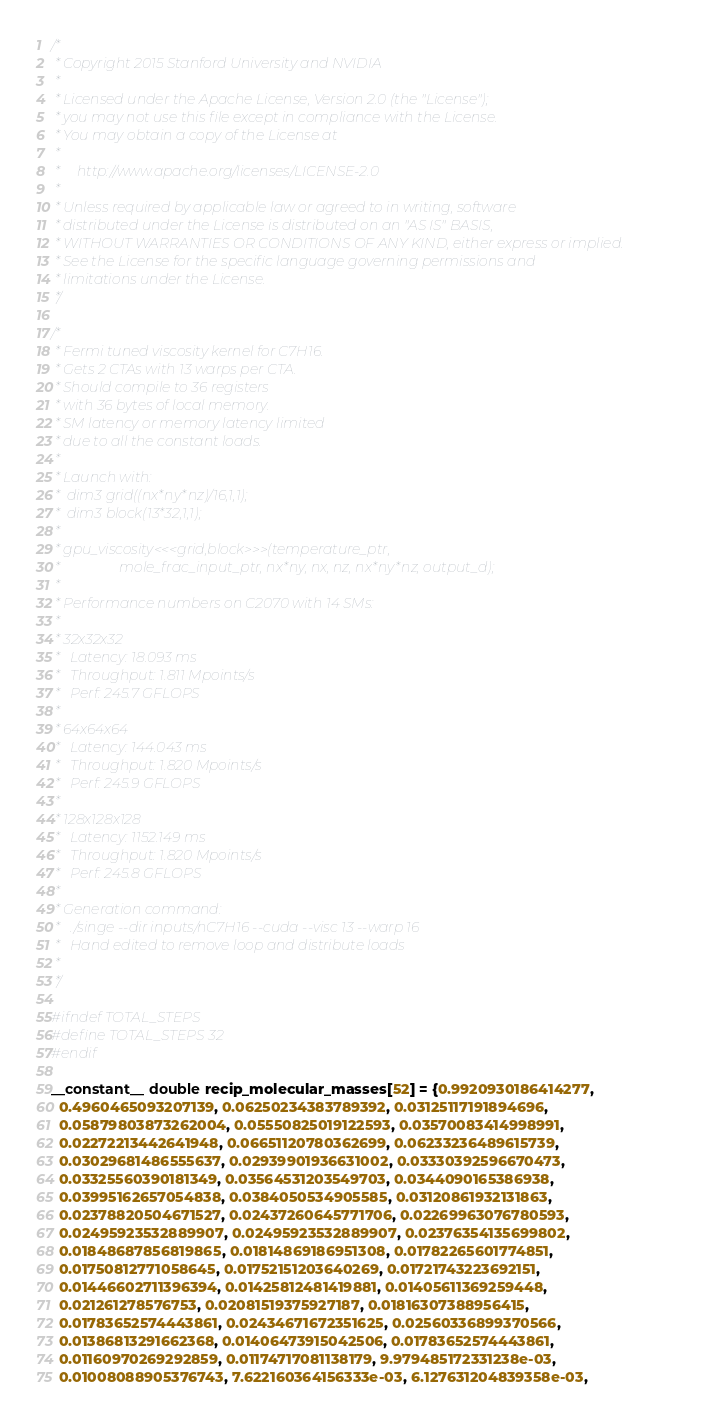<code> <loc_0><loc_0><loc_500><loc_500><_Cuda_>/*
 * Copyright 2015 Stanford University and NVIDIA
 *
 * Licensed under the Apache License, Version 2.0 (the "License");
 * you may not use this file except in compliance with the License.
 * You may obtain a copy of the License at
 *
 *     http://www.apache.org/licenses/LICENSE-2.0
 *
 * Unless required by applicable law or agreed to in writing, software
 * distributed under the License is distributed on an "AS IS" BASIS,
 * WITHOUT WARRANTIES OR CONDITIONS OF ANY KIND, either express or implied.
 * See the License for the specific language governing permissions and
 * limitations under the License.
 */

/*
 * Fermi tuned viscosity kernel for C7H16.
 * Gets 2 CTAs with 13 warps per CTA.
 * Should compile to 36 registers
 * with 36 bytes of local memory.
 * SM latency or memory latency limited
 * due to all the constant loads.
 *
 * Launch with:
 *  dim3 grid((nx*ny*nz)/16,1,1);
 *  dim3 block(13*32,1,1);
 *
 * gpu_viscosity<<<grid,block>>>(temperature_ptr, 
 *                 mole_frac_input_ptr, nx*ny, nx, nz, nx*ny*nz, output_d);
 *
 * Performance numbers on C2070 with 14 SMs:
 * 
 * 32x32x32
 *   Latency: 18.093 ms
 *   Throughput: 1.811 Mpoints/s
 *   Perf: 245.7 GFLOPS
 *
 * 64x64x64
 *   Latency: 144.043 ms
 *   Throughput: 1.820 Mpoints/s
 *   Perf: 245.9 GFLOPS
 *
 * 128x128x128
 *   Latency: 1152.149 ms
 *   Throughput: 1.820 Mpoints/s
 *   Perf: 245.8 GFLOPS
 *
 * Generation command:
 *   ./singe --dir inputs/nC7H16 --cuda --visc 13 --warp 16
 *   Hand edited to remove loop and distribute loads
 *
 */

#ifndef TOTAL_STEPS
#define TOTAL_STEPS 32
#endif

__constant__ double recip_molecular_masses[52] = {0.9920930186414277, 
  0.4960465093207139, 0.06250234383789392, 0.03125117191894696, 
  0.05879803873262004, 0.05550825019122593, 0.03570083414998991, 
  0.02272213442641948, 0.06651120780362699, 0.06233236489615739, 
  0.03029681486555637, 0.02939901936631002, 0.03330392596670473, 
  0.03325560390181349, 0.03564531203549703, 0.0344090165386938, 
  0.03995162657054838, 0.0384050534905585, 0.03120861932131863, 
  0.02378820504671527, 0.02437260645771706, 0.02269963076780593, 
  0.02495923532889907, 0.02495923532889907, 0.02376354135699802, 
  0.01848687856819865, 0.01814869186951308, 0.01782265601774851, 
  0.01750812771058645, 0.01752151203640269, 0.01721743223692151, 
  0.01446602711396394, 0.01425812481419881, 0.01405611369259448, 
  0.021261278576753, 0.02081519375927187, 0.01816307388956415, 
  0.01783652574443861, 0.02434671672351625, 0.02560336899370566, 
  0.01386813291662368, 0.01406473915042506, 0.01783652574443861, 
  0.01160970269292859, 0.01174717081138179, 9.979485172331238e-03, 
  0.01008088905376743, 7.622160364156333e-03, 6.127631204839358e-03, </code> 